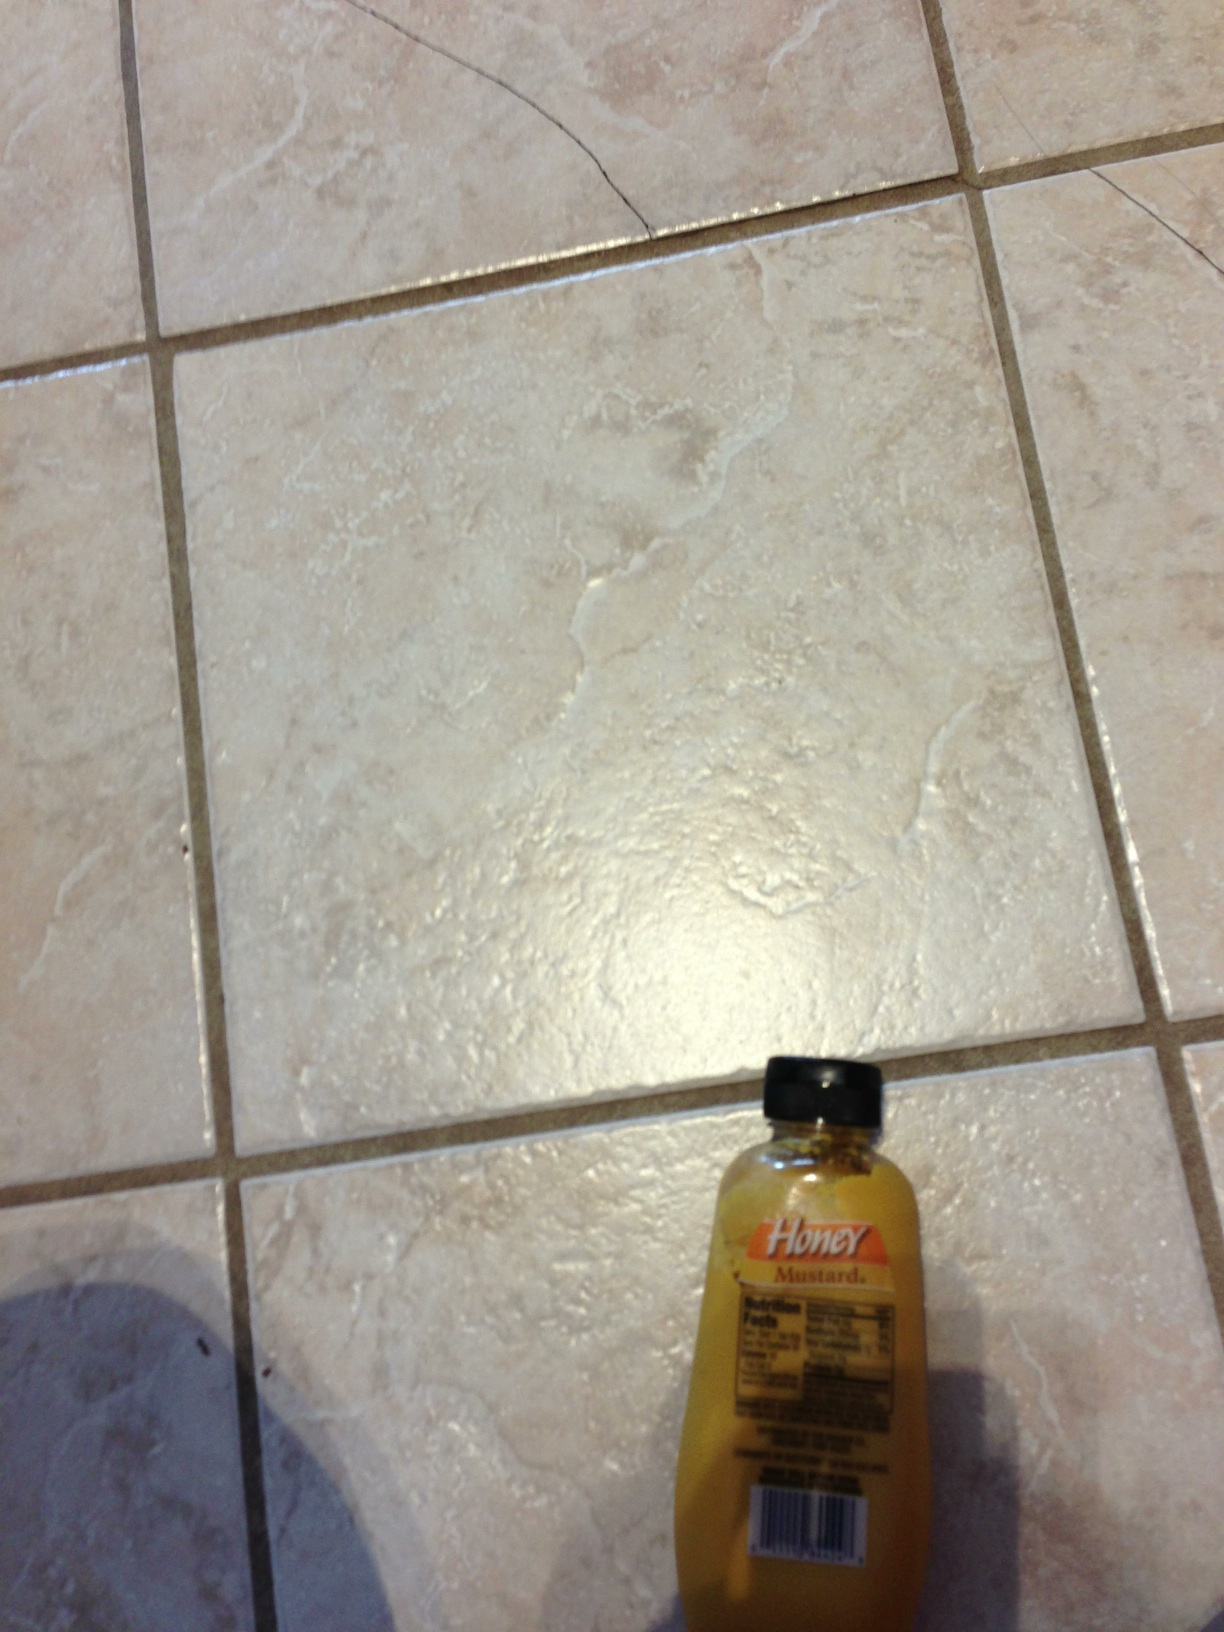Can you identify the product and describe its uses? The product in the image is a bottle of honey mustard salad dressing. Honey mustard is commonly used as a dressing for salads, a dip for chicken tenders and fries, and a spread for sandwiches and burgers. Its sweet and tangy flavor can enhance various dishes, making it a versatile addition to your pantry. 